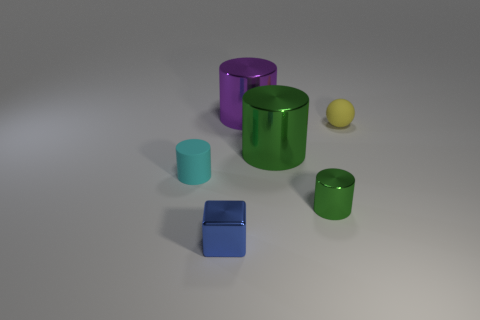What is the material of the other cylinder that is the same color as the tiny shiny cylinder? metal 